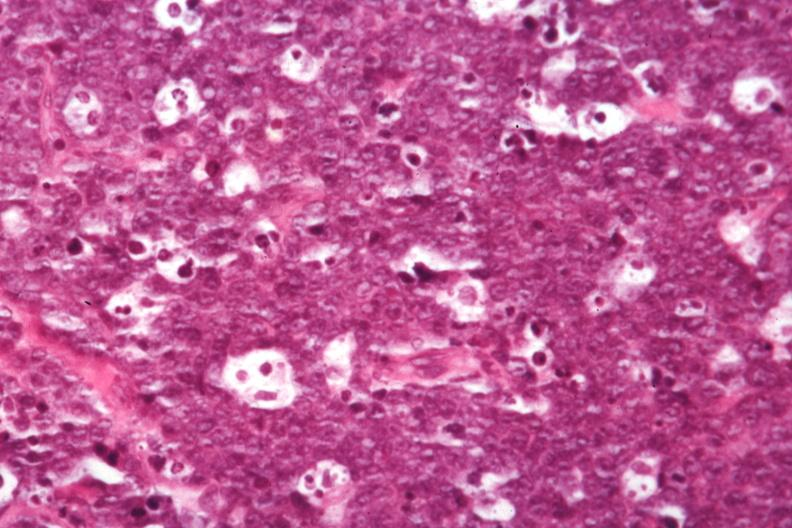s burkitts lymphoma present?
Answer the question using a single word or phrase. Yes 